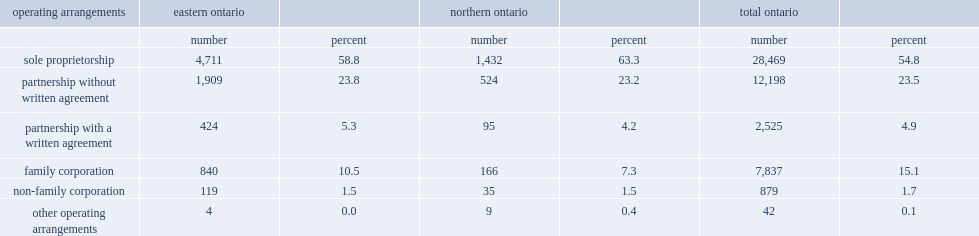Parse the table in full. {'header': ['operating arrangements', 'eastern ontario', '', 'northern ontario', '', 'total ontario', ''], 'rows': [['', 'number', 'percent', 'number', 'percent', 'number', 'percent'], ['sole proprietorship', '4,711', '58.8', '1,432', '63.3', '28,469', '54.8'], ['partnership without written agreement', '1,909', '23.8', '524', '23.2', '12,198', '23.5'], ['partnership with a written agreement', '424', '5.3', '95', '4.2', '2,525', '4.9'], ['family corporation', '840', '10.5', '166', '7.3', '7,837', '15.1'], ['non-family corporation', '119', '1.5', '35', '1.5', '879', '1.7'], ['other operating arrangements', '4', '0.0', '9', '0.4', '42', '0.1']]} Which type of operationg arrangement in northern and eastern ontario has a higher proportion than the entire province? Sole proprietorship. 